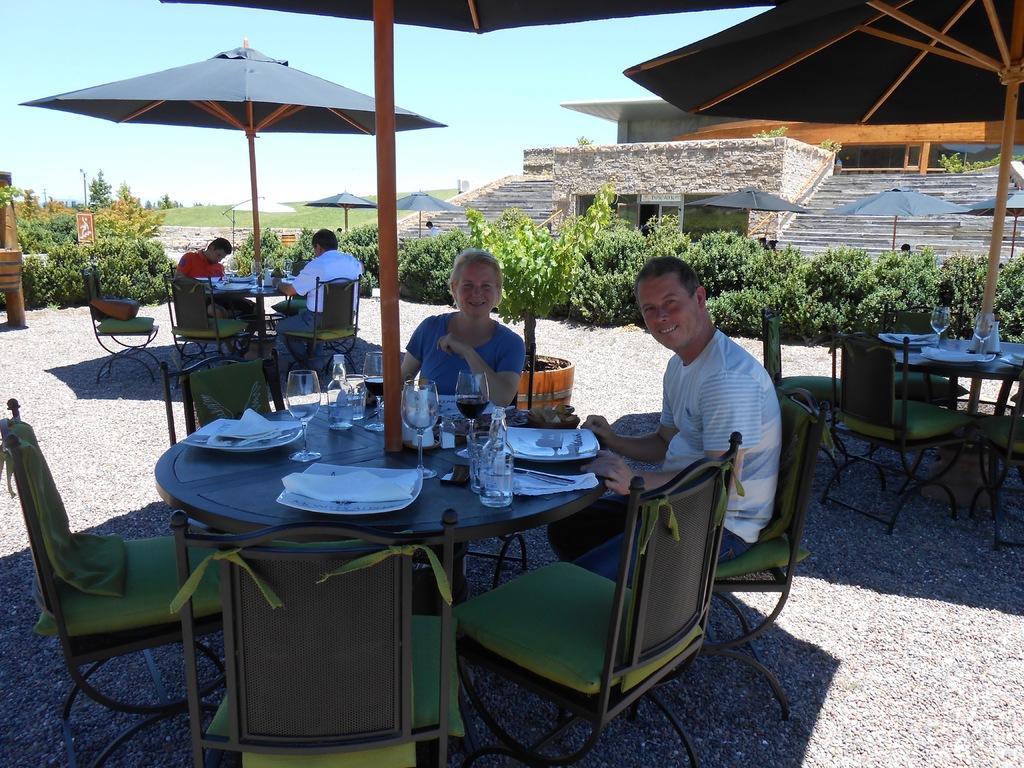Can you describe this image briefly? In the given image we can see four person sitting on a chair. This is a chair, table, plate, tissue paper, wine glass and a bottle. There are many plants around and umbrella and the sky is in pale blue color. 